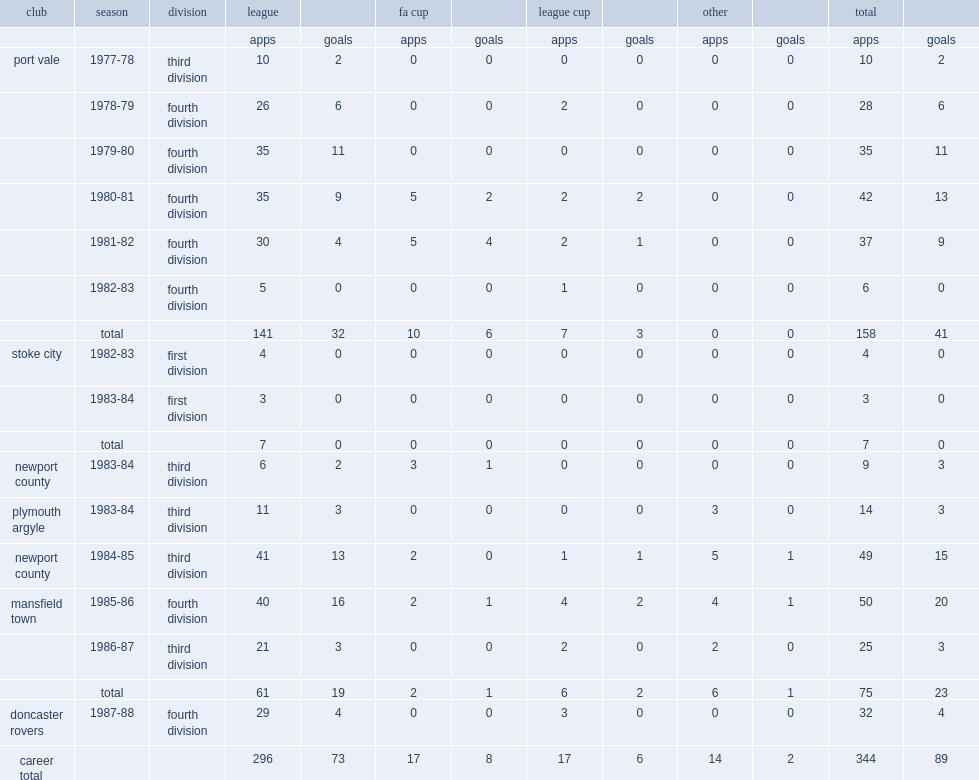Which division did neville chamberlain appear in mansfield town in 1985-86? Fourth division. 